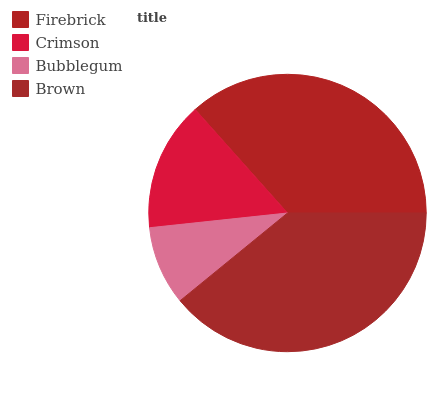Is Bubblegum the minimum?
Answer yes or no. Yes. Is Brown the maximum?
Answer yes or no. Yes. Is Crimson the minimum?
Answer yes or no. No. Is Crimson the maximum?
Answer yes or no. No. Is Firebrick greater than Crimson?
Answer yes or no. Yes. Is Crimson less than Firebrick?
Answer yes or no. Yes. Is Crimson greater than Firebrick?
Answer yes or no. No. Is Firebrick less than Crimson?
Answer yes or no. No. Is Firebrick the high median?
Answer yes or no. Yes. Is Crimson the low median?
Answer yes or no. Yes. Is Crimson the high median?
Answer yes or no. No. Is Brown the low median?
Answer yes or no. No. 